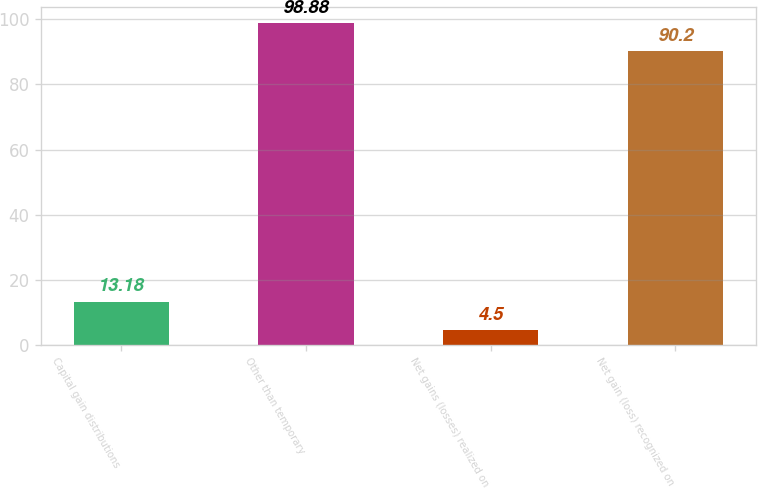<chart> <loc_0><loc_0><loc_500><loc_500><bar_chart><fcel>Capital gain distributions<fcel>Other than temporary<fcel>Net gains (losses) realized on<fcel>Net gain (loss) recognized on<nl><fcel>13.18<fcel>98.88<fcel>4.5<fcel>90.2<nl></chart> 